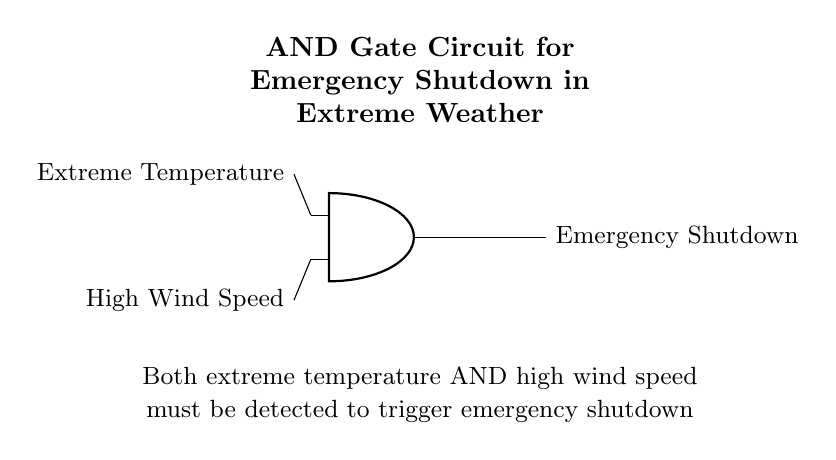What type of logic gate is shown in the circuit? The circuit diagram displays an AND gate, which is indicated by the symbol labeled as "AND" within the diagram.
Answer: AND gate What are the two inputs to the AND gate? The inputs are labeled as "Extreme Temperature" and "High Wind Speed," which are positioned leading into the AND gate's input ports.
Answer: Extreme Temperature, High Wind Speed What is the output of the circuit labeled as? The output of the circuit is labeled "Emergency Shutdown," which is shown branching out from the AND gate.
Answer: Emergency Shutdown How many inputs does the AND gate have? The AND gate has two inputs, as depicted by the two input lines leading into the AND gate symbol in the circuit.
Answer: Two What condition must be met for the emergency shutdown to activate? Both conditions of extreme temperature and high wind speed need to be met simultaneously as stated in the explanation that accompanies the diagram.
Answer: Both conditions met If either input is low, what happens to the output? If either input is low, the output will not activate the emergency shutdown, as the AND gate requires both inputs to be high for it to output a high signal.
Answer: Output is low 